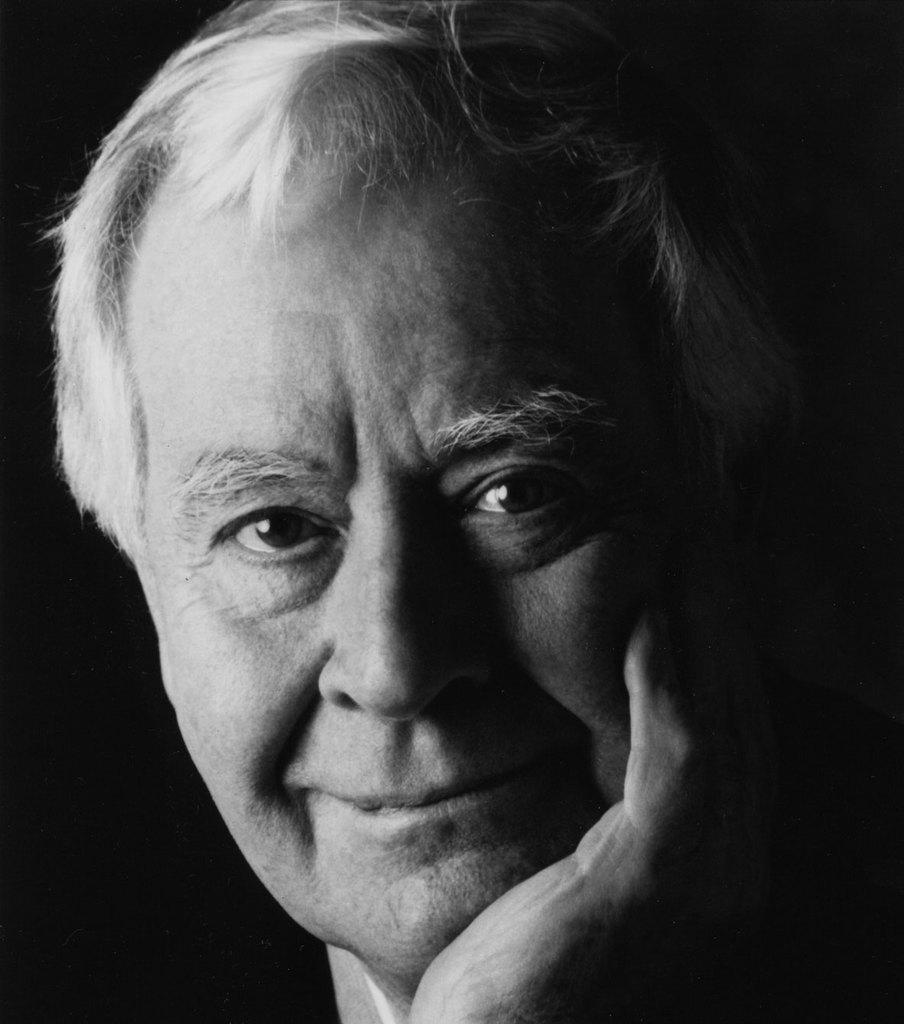Who is the main subject in the image? There is a man in the middle of the image. What can be observed about the background of the image? The background of the image is dark. What type of leather is being used to create the rod in the image? There is no rod or leather present in the image. 